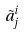Convert formula to latex. <formula><loc_0><loc_0><loc_500><loc_500>\tilde { a } _ { j } ^ { i }</formula> 